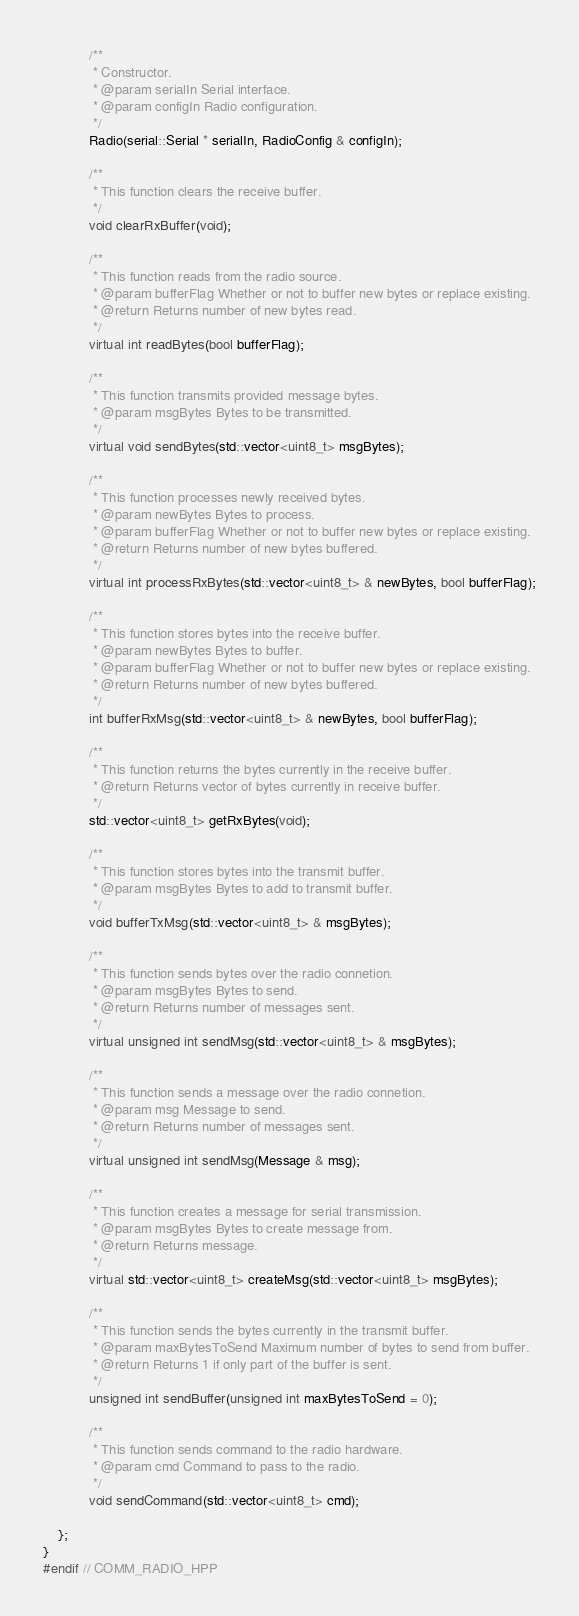<code> <loc_0><loc_0><loc_500><loc_500><_C++_>
            /**
             * Constructor.
             * @param serialIn Serial interface.
             * @param configIn Radio configuration.
             */
            Radio(serial::Serial * serialIn, RadioConfig & configIn);

            /**
             * This function clears the receive buffer.
             */
            void clearRxBuffer(void);

            /**
             * This function reads from the radio source.
             * @param bufferFlag Whether or not to buffer new bytes or replace existing.
             * @return Returns number of new bytes read.
             */
            virtual int readBytes(bool bufferFlag);

            /**
             * This function transmits provided message bytes.
             * @param msgBytes Bytes to be transmitted.
             */
            virtual void sendBytes(std::vector<uint8_t> msgBytes);

            /**
             * This function processes newly received bytes.
             * @param newBytes Bytes to process.
             * @param bufferFlag Whether or not to buffer new bytes or replace existing.
             * @return Returns number of new bytes buffered.
             */
            virtual int processRxBytes(std::vector<uint8_t> & newBytes, bool bufferFlag);

            /**
             * This function stores bytes into the receive buffer.
             * @param newBytes Bytes to buffer.
             * @param bufferFlag Whether or not to buffer new bytes or replace existing.
             * @return Returns number of new bytes buffered.
             */
            int bufferRxMsg(std::vector<uint8_t> & newBytes, bool bufferFlag);

            /**
             * This function returns the bytes currently in the receive buffer.
             * @return Returns vector of bytes currently in receive buffer.
             */
            std::vector<uint8_t> getRxBytes(void);

            /**
             * This function stores bytes into the transmit buffer.
             * @param msgBytes Bytes to add to transmit buffer.
             */
            void bufferTxMsg(std::vector<uint8_t> & msgBytes);

            /**
             * This function sends bytes over the radio connetion.
             * @param msgBytes Bytes to send.
             * @return Returns number of messages sent.
             */
            virtual unsigned int sendMsg(std::vector<uint8_t> & msgBytes);

            /**
             * This function sends a message over the radio connetion.
             * @param msg Message to send.
             * @return Returns number of messages sent.
             */
            virtual unsigned int sendMsg(Message & msg);
            
            /**
             * This function creates a message for serial transmission.
             * @param msgBytes Bytes to create message from.
             * @return Returns message.
             */
            virtual std::vector<uint8_t> createMsg(std::vector<uint8_t> msgBytes);

            /**
             * This function sends the bytes currently in the transmit buffer.
             * @param maxBytesToSend Maximum number of bytes to send from buffer.
             * @return Returns 1 if only part of the buffer is sent.
             */
            unsigned int sendBuffer(unsigned int maxBytesToSend = 0);
    
            /**
             * This function sends command to the radio hardware.
             * @param cmd Command to pass to the radio.
             */
            void sendCommand(std::vector<uint8_t> cmd);

    };
}
#endif // COMM_RADIO_HPP
</code> 